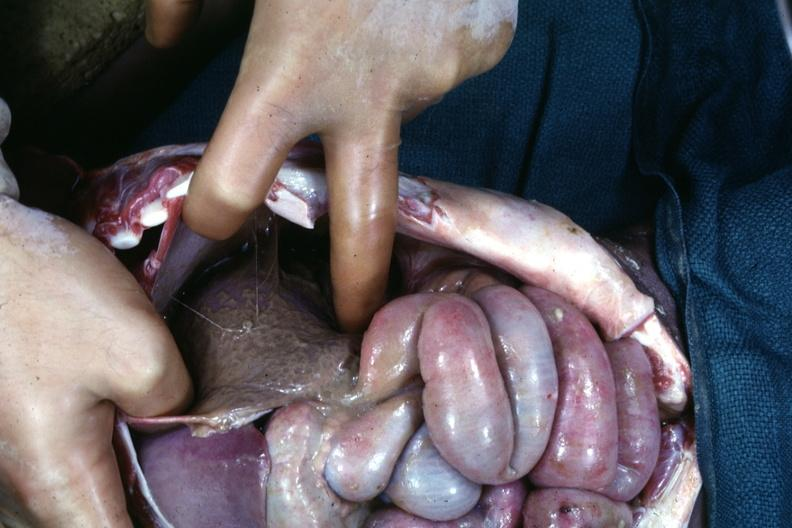what is present?
Answer the question using a single word or phrase. Subdiaphragmatic abscess 